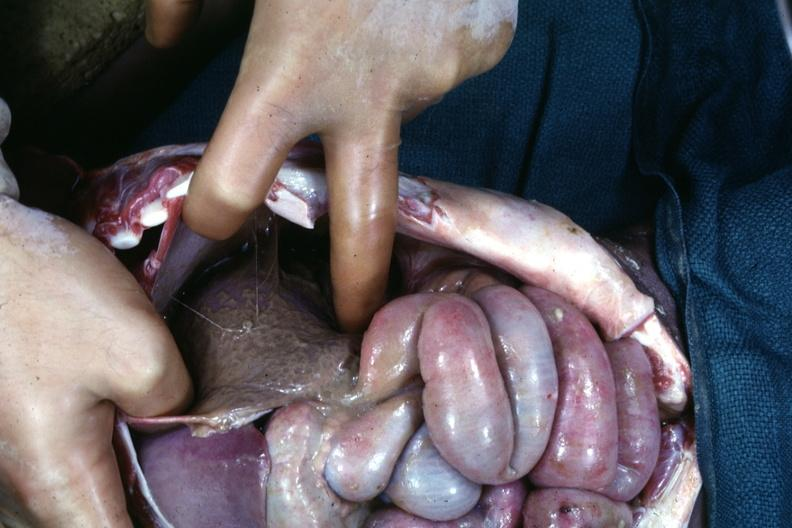what is present?
Answer the question using a single word or phrase. Subdiaphragmatic abscess 